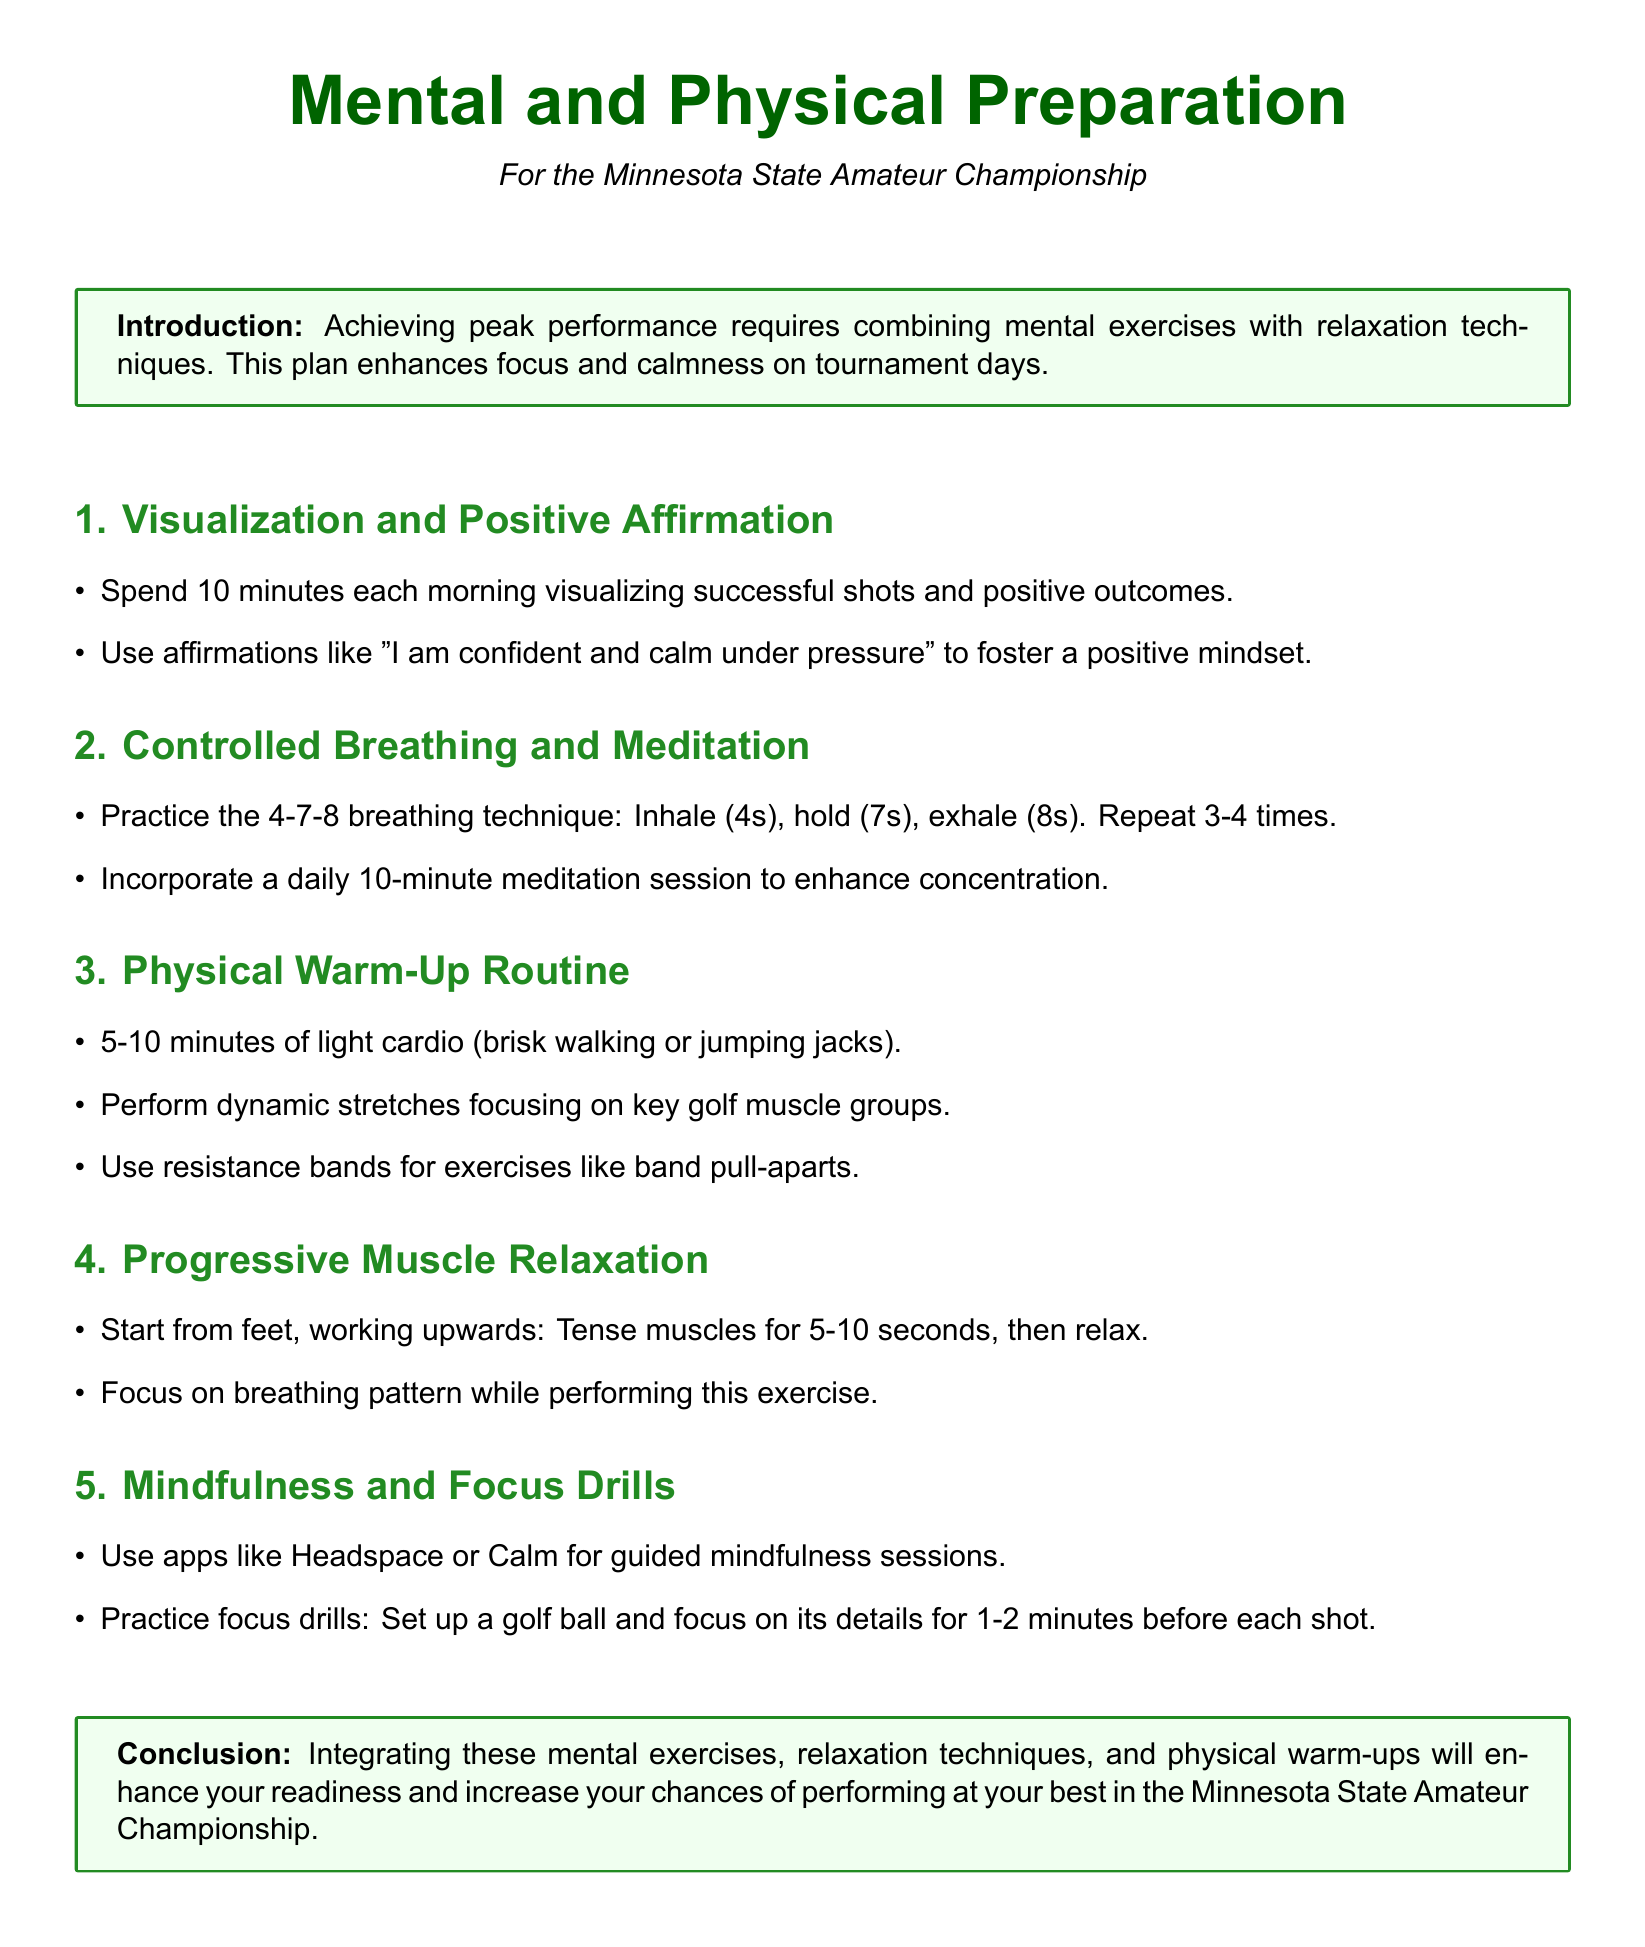What is the target event for preparation? The document specifies the Minnesota State Amateur Championship as the target event for preparation.
Answer: Minnesota State Amateur Championship How long should you spend on visualization each morning? The document states to spend 10 minutes each morning visualizing successful shots.
Answer: 10 minutes What is the breathing technique recommended? The document mentions the 4-7-8 breathing technique as a method to enhance relaxation.
Answer: 4-7-8 What type of stretches should be performed in the warm-up routine? The warm-up routine focuses on dynamic stretches that target key golf muscle groups.
Answer: Dynamic stretches What apps are suggested for mindfulness sessions? The document recommends using apps like Headspace or Calm for guided mindfulness sessions.
Answer: Headspace or Calm What is the first step in Progressive Muscle Relaxation? The document indicates to start from the feet while performing Progressive Muscle Relaxation.
Answer: Feet How many times should the breathing technique be repeated? The document advises to repeat the 4-7-8 breathing technique 3-4 times.
Answer: 3-4 times What is the main goal of combining mental exercises with relaxation techniques? The main goal as stated in the introduction is to enhance focus and calmness on tournament days.
Answer: Enhance focus and calmness What should be focused on during the focus drills? The document specifies to focus on the details of a golf ball during focus drills.
Answer: Golf ball details 